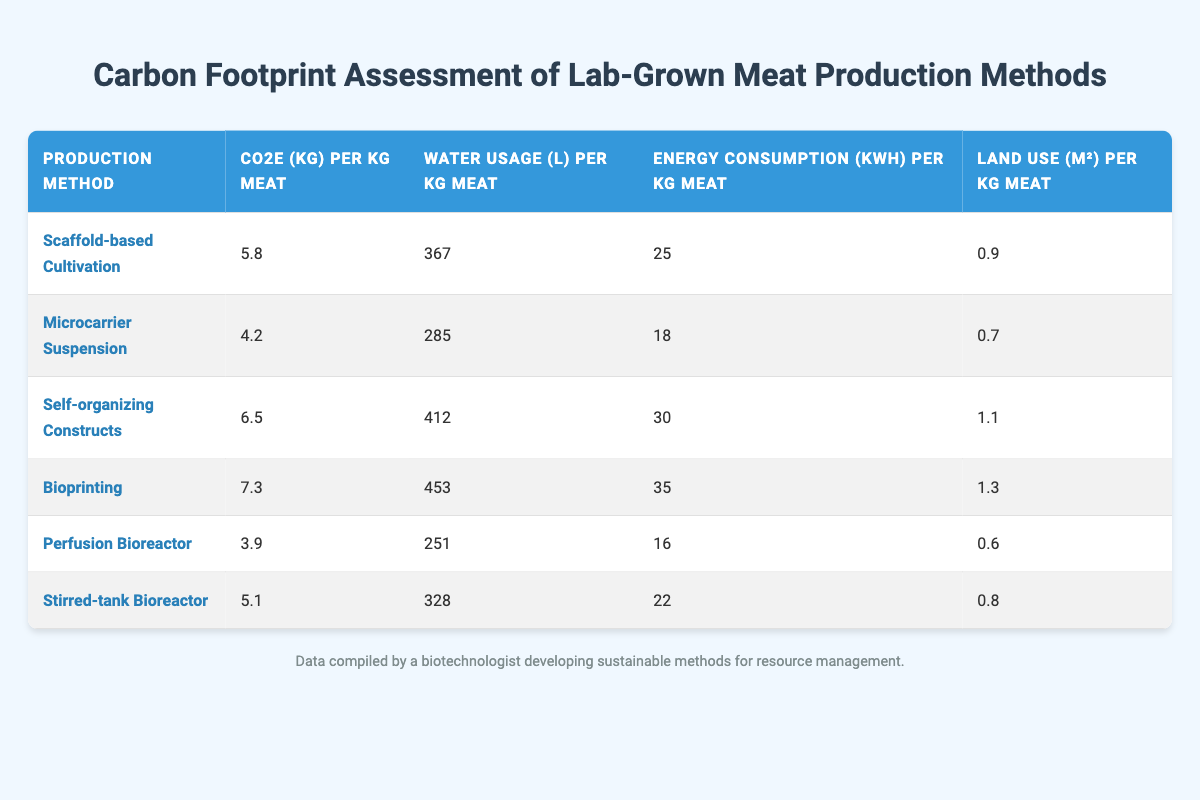What is the CO2e emissions for Microcarrier Suspension? According to the table, the CO2e emissions per kg of meat produced by the Microcarrier Suspension method is listed as 4.2 kg.
Answer: 4.2 kg Which production method has the highest water usage? By scanning the table, we can identify that Bioprinting has the highest water usage at 453 liters per kg of meat.
Answer: Bioprinting What is the average energy consumption for all production methods? To calculate the average energy consumption, we add the energy values: (25 + 18 + 30 + 35 + 16 + 22) = 146 kWh. Then divide by the number of methods (6): 146 / 6 = 24.33 kWh.
Answer: 24.33 kWh Is the land use for Scaffold-based Cultivation greater than that for Perfusion Bioreactor? The land use for Scaffold-based Cultivation is 0.9 m², and for Perfusion Bioreactor is 0.6 m². Since 0.9 > 0.6, the statement is true.
Answer: Yes Which production method has the lowest carbon footprint? By comparing the CO2e values, Perfusion Bioreactor has the lowest carbon footprint at 3.9 kg per kg of meat, which is the smallest value listed in the table.
Answer: Perfusion Bioreactor Which method requires more energy: Self-organizing Constructs or Scaffold-based Cultivation? The table shows Self-organizing Constructs require 30 kWh per kg, while Scaffold-based Cultivation requires 25 kWh. Since 30 > 25, Self-organizing Constructs require more energy.
Answer: Self-organizing Constructs What is the difference in water usage between Bioprinting and Stirred-tank Bioreactor? The water usage for Bioprinting is 453 L and for Stirred-tank Bioreactor it is 328 L. The difference is 453 - 328 = 125 L.
Answer: 125 L Which production method has the second highest carbon emissions? By observing the CO2e emissions, we see that the second highest is Self-organizing Constructs at 6.5 kg per kg of meat, second to Bioprinting with 7.3 kg.
Answer: Self-organizing Constructs Is Microcarrier Suspension more sustainable than Bioprinting based on CO2e emissions? Microcarrier Suspension has CO2e emissions of 4.2 kg, while Bioprinting has 7.3 kg. Since 4.2 < 7.3, Microcarrier Suspension is more sustainable in terms of carbon emissions.
Answer: Yes 